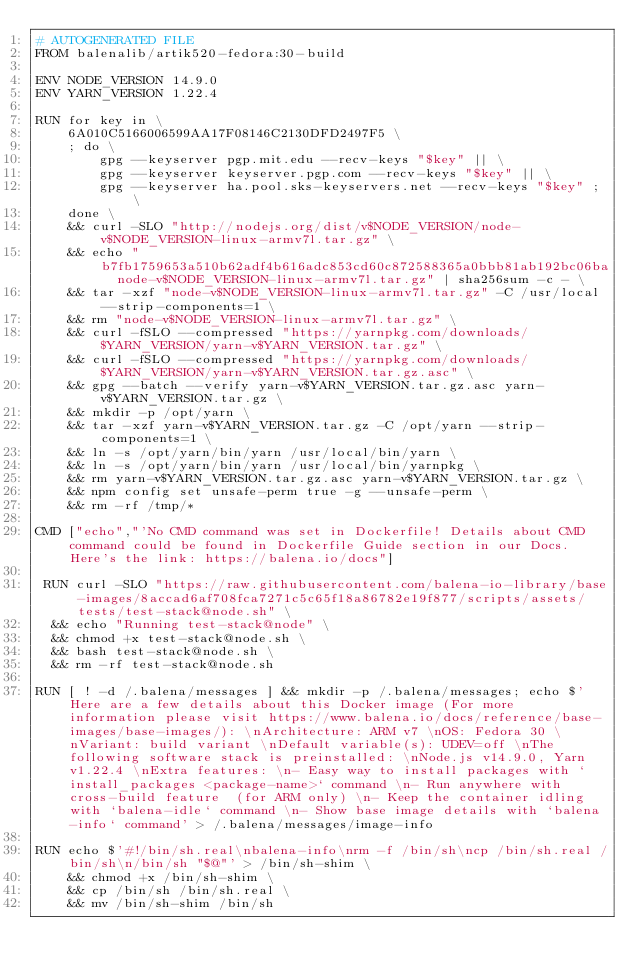Convert code to text. <code><loc_0><loc_0><loc_500><loc_500><_Dockerfile_># AUTOGENERATED FILE
FROM balenalib/artik520-fedora:30-build

ENV NODE_VERSION 14.9.0
ENV YARN_VERSION 1.22.4

RUN for key in \
	6A010C5166006599AA17F08146C2130DFD2497F5 \
	; do \
		gpg --keyserver pgp.mit.edu --recv-keys "$key" || \
		gpg --keyserver keyserver.pgp.com --recv-keys "$key" || \
		gpg --keyserver ha.pool.sks-keyservers.net --recv-keys "$key" ; \
	done \
	&& curl -SLO "http://nodejs.org/dist/v$NODE_VERSION/node-v$NODE_VERSION-linux-armv7l.tar.gz" \
	&& echo "b7fb1759653a510b62adf4b616adc853cd60c872588365a0bbb81ab192bc06ba  node-v$NODE_VERSION-linux-armv7l.tar.gz" | sha256sum -c - \
	&& tar -xzf "node-v$NODE_VERSION-linux-armv7l.tar.gz" -C /usr/local --strip-components=1 \
	&& rm "node-v$NODE_VERSION-linux-armv7l.tar.gz" \
	&& curl -fSLO --compressed "https://yarnpkg.com/downloads/$YARN_VERSION/yarn-v$YARN_VERSION.tar.gz" \
	&& curl -fSLO --compressed "https://yarnpkg.com/downloads/$YARN_VERSION/yarn-v$YARN_VERSION.tar.gz.asc" \
	&& gpg --batch --verify yarn-v$YARN_VERSION.tar.gz.asc yarn-v$YARN_VERSION.tar.gz \
	&& mkdir -p /opt/yarn \
	&& tar -xzf yarn-v$YARN_VERSION.tar.gz -C /opt/yarn --strip-components=1 \
	&& ln -s /opt/yarn/bin/yarn /usr/local/bin/yarn \
	&& ln -s /opt/yarn/bin/yarn /usr/local/bin/yarnpkg \
	&& rm yarn-v$YARN_VERSION.tar.gz.asc yarn-v$YARN_VERSION.tar.gz \
	&& npm config set unsafe-perm true -g --unsafe-perm \
	&& rm -rf /tmp/*

CMD ["echo","'No CMD command was set in Dockerfile! Details about CMD command could be found in Dockerfile Guide section in our Docs. Here's the link: https://balena.io/docs"]

 RUN curl -SLO "https://raw.githubusercontent.com/balena-io-library/base-images/8accad6af708fca7271c5c65f18a86782e19f877/scripts/assets/tests/test-stack@node.sh" \
  && echo "Running test-stack@node" \
  && chmod +x test-stack@node.sh \
  && bash test-stack@node.sh \
  && rm -rf test-stack@node.sh 

RUN [ ! -d /.balena/messages ] && mkdir -p /.balena/messages; echo $'Here are a few details about this Docker image (For more information please visit https://www.balena.io/docs/reference/base-images/base-images/): \nArchitecture: ARM v7 \nOS: Fedora 30 \nVariant: build variant \nDefault variable(s): UDEV=off \nThe following software stack is preinstalled: \nNode.js v14.9.0, Yarn v1.22.4 \nExtra features: \n- Easy way to install packages with `install_packages <package-name>` command \n- Run anywhere with cross-build feature  (for ARM only) \n- Keep the container idling with `balena-idle` command \n- Show base image details with `balena-info` command' > /.balena/messages/image-info

RUN echo $'#!/bin/sh.real\nbalena-info\nrm -f /bin/sh\ncp /bin/sh.real /bin/sh\n/bin/sh "$@"' > /bin/sh-shim \
	&& chmod +x /bin/sh-shim \
	&& cp /bin/sh /bin/sh.real \
	&& mv /bin/sh-shim /bin/sh</code> 